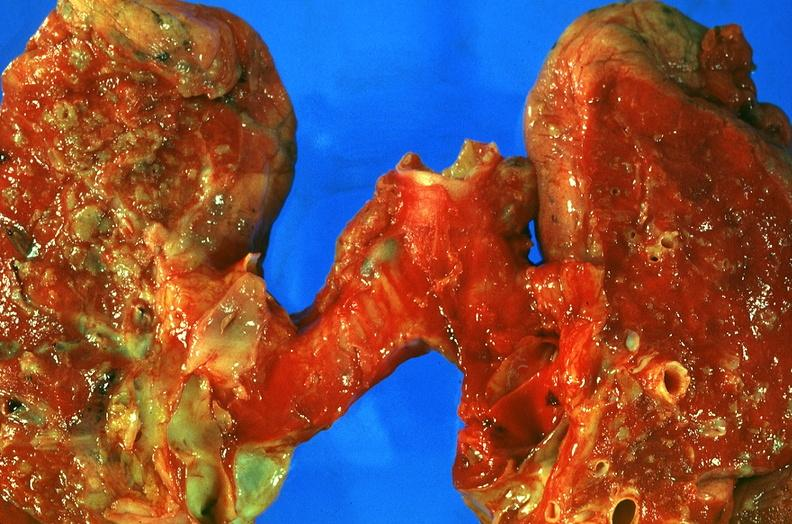s this myoma present?
Answer the question using a single word or phrase. No 